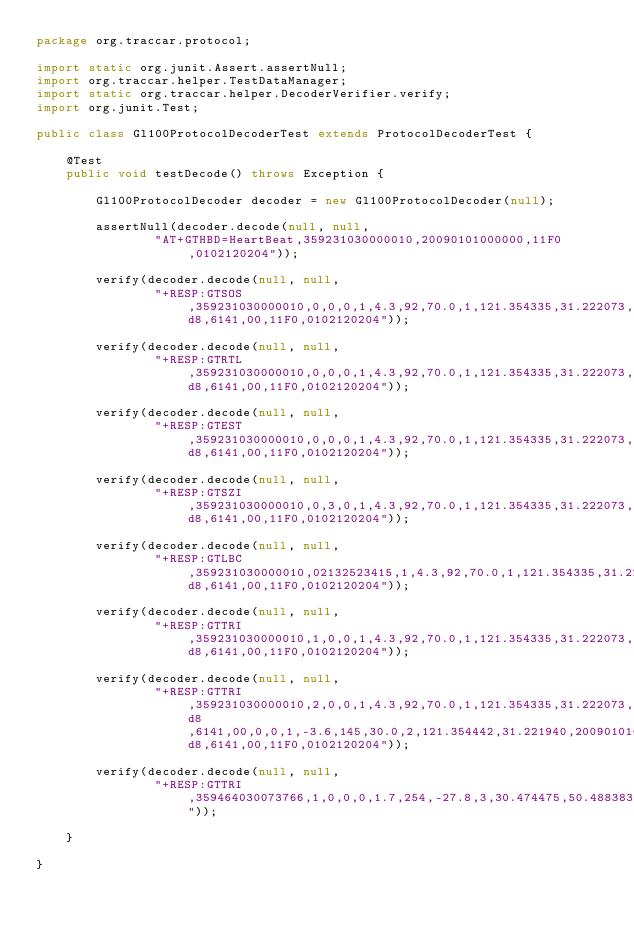Convert code to text. <code><loc_0><loc_0><loc_500><loc_500><_Java_>package org.traccar.protocol;

import static org.junit.Assert.assertNull;
import org.traccar.helper.TestDataManager;
import static org.traccar.helper.DecoderVerifier.verify;
import org.junit.Test;

public class Gl100ProtocolDecoderTest extends ProtocolDecoderTest {

    @Test
    public void testDecode() throws Exception {

        Gl100ProtocolDecoder decoder = new Gl100ProtocolDecoder(null);

        assertNull(decoder.decode(null, null,
                "AT+GTHBD=HeartBeat,359231030000010,20090101000000,11F0,0102120204"));

        verify(decoder.decode(null, null,
                "+RESP:GTSOS,359231030000010,0,0,0,1,4.3,92,70.0,1,121.354335,31.222073,20090101000000,0460,0000,18d8,6141,00,11F0,0102120204"));

        verify(decoder.decode(null, null,
                "+RESP:GTRTL,359231030000010,0,0,0,1,4.3,92,70.0,1,121.354335,31.222073,20090101000000,0460,0000,18d8,6141,00,11F0,0102120204"));

        verify(decoder.decode(null, null,
                "+RESP:GTEST,359231030000010,0,0,0,1,4.3,92,70.0,1,121.354335,31.222073,20090101000000,0460,0000,18d8,6141,00,11F0,0102120204"));

        verify(decoder.decode(null, null,
                "+RESP:GTSZI,359231030000010,0,3,0,1,4.3,92,70.0,1,121.354335,31.222073,20090101000000,0460,0000,18d8,6141,00,11F0,0102120204"));

        verify(decoder.decode(null, null,
                "+RESP:GTLBC,359231030000010,02132523415,1,4.3,92,70.0,1,121.354335,31.222073,20090101000000,0460,0000,18d8,6141,00,11F0,0102120204"));

        verify(decoder.decode(null, null,
                "+RESP:GTTRI,359231030000010,1,0,0,1,4.3,92,70.0,1,121.354335,31.222073,20090101000000,0460,0000,18d8,6141,00,11F0,0102120204"));

        verify(decoder.decode(null, null,
                "+RESP:GTTRI,359231030000010,2,0,0,1,4.3,92,70.0,1,121.354335,31.222073,20090101000000,0460,0000,18d8,6141,00,0,0,1,-3.6,145,30.0,2,121.354442,31.221940,20090101000100,0460,0000,18d8,6141,00,11F0,0102120204"));

        verify(decoder.decode(null, null,
                "+RESP:GTTRI,359464030073766,1,0,0,0,1.7,254,-27.8,3,30.474475,50.488383,20131107155511,0255,0003,6995,4761,00,0071,0103090402"));

    }

}
</code> 